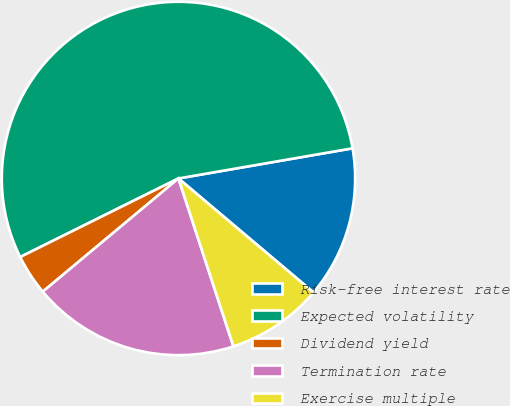Convert chart to OTSL. <chart><loc_0><loc_0><loc_500><loc_500><pie_chart><fcel>Risk-free interest rate<fcel>Expected volatility<fcel>Dividend yield<fcel>Termination rate<fcel>Exercise multiple<nl><fcel>13.89%<fcel>54.61%<fcel>3.73%<fcel>18.97%<fcel>8.81%<nl></chart> 